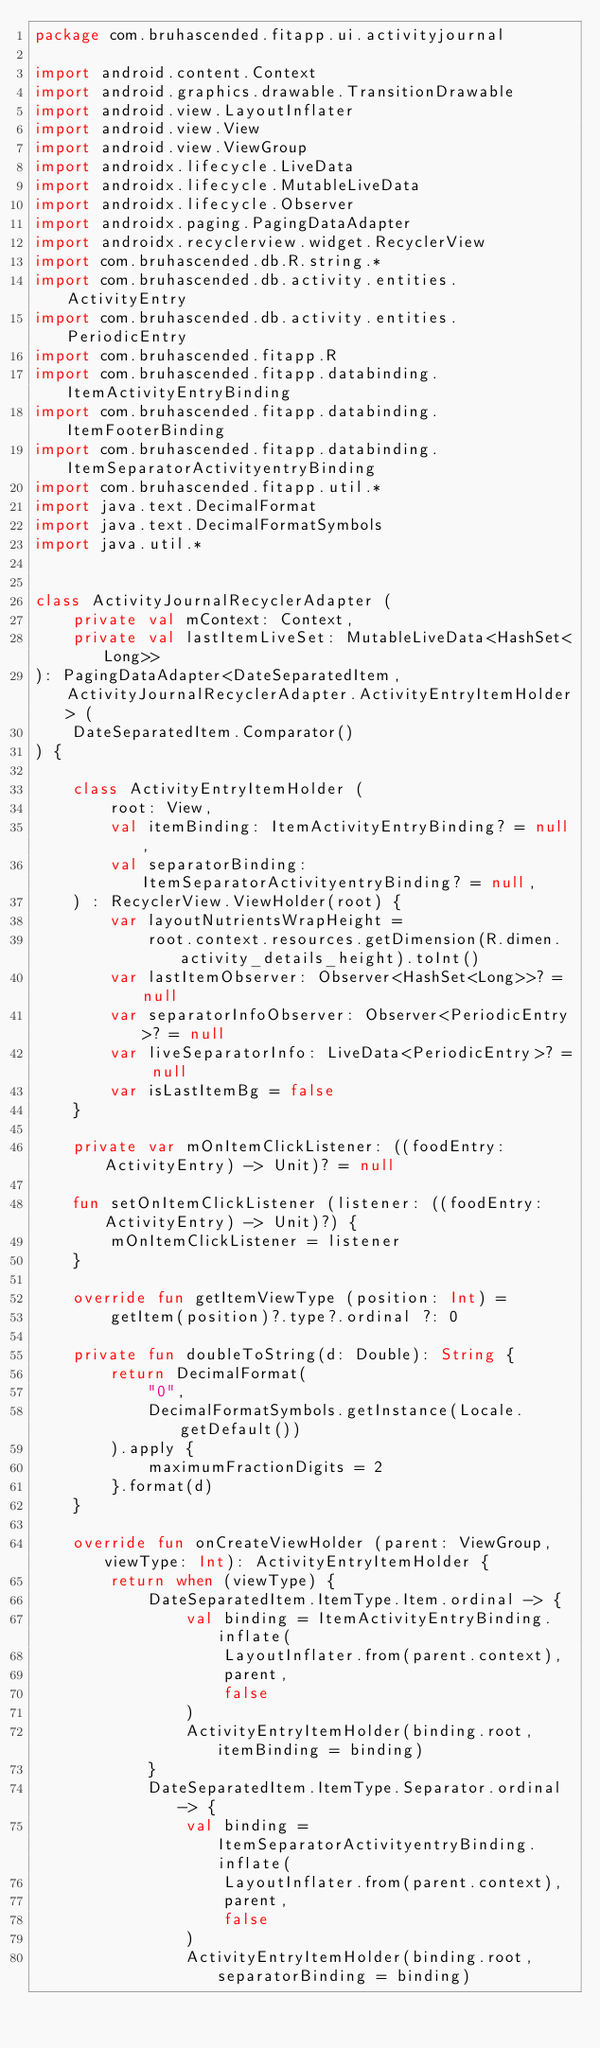Convert code to text. <code><loc_0><loc_0><loc_500><loc_500><_Kotlin_>package com.bruhascended.fitapp.ui.activityjournal

import android.content.Context
import android.graphics.drawable.TransitionDrawable
import android.view.LayoutInflater
import android.view.View
import android.view.ViewGroup
import androidx.lifecycle.LiveData
import androidx.lifecycle.MutableLiveData
import androidx.lifecycle.Observer
import androidx.paging.PagingDataAdapter
import androidx.recyclerview.widget.RecyclerView
import com.bruhascended.db.R.string.*
import com.bruhascended.db.activity.entities.ActivityEntry
import com.bruhascended.db.activity.entities.PeriodicEntry
import com.bruhascended.fitapp.R
import com.bruhascended.fitapp.databinding.ItemActivityEntryBinding
import com.bruhascended.fitapp.databinding.ItemFooterBinding
import com.bruhascended.fitapp.databinding.ItemSeparatorActivityentryBinding
import com.bruhascended.fitapp.util.*
import java.text.DecimalFormat
import java.text.DecimalFormatSymbols
import java.util.*


class ActivityJournalRecyclerAdapter (
    private val mContext: Context,
    private val lastItemLiveSet: MutableLiveData<HashSet<Long>>
): PagingDataAdapter<DateSeparatedItem, ActivityJournalRecyclerAdapter.ActivityEntryItemHolder> (
    DateSeparatedItem.Comparator()
) {

    class ActivityEntryItemHolder (
        root: View,
        val itemBinding: ItemActivityEntryBinding? = null,
        val separatorBinding: ItemSeparatorActivityentryBinding? = null,
    ) : RecyclerView.ViewHolder(root) {
        var layoutNutrientsWrapHeight =
            root.context.resources.getDimension(R.dimen.activity_details_height).toInt()
        var lastItemObserver: Observer<HashSet<Long>>? = null
        var separatorInfoObserver: Observer<PeriodicEntry>? = null
        var liveSeparatorInfo: LiveData<PeriodicEntry>? = null
        var isLastItemBg = false
    }

    private var mOnItemClickListener: ((foodEntry: ActivityEntry) -> Unit)? = null

    fun setOnItemClickListener (listener: ((foodEntry: ActivityEntry) -> Unit)?) {
        mOnItemClickListener = listener
    }

    override fun getItemViewType (position: Int) =
        getItem(position)?.type?.ordinal ?: 0

    private fun doubleToString(d: Double): String {
        return DecimalFormat(
            "0",
            DecimalFormatSymbols.getInstance(Locale.getDefault())
        ).apply {
            maximumFractionDigits = 2
        }.format(d)
    }

    override fun onCreateViewHolder (parent: ViewGroup, viewType: Int): ActivityEntryItemHolder {
        return when (viewType) {
            DateSeparatedItem.ItemType.Item.ordinal -> {
                val binding = ItemActivityEntryBinding.inflate(
                    LayoutInflater.from(parent.context),
                    parent,
                    false
                )
                ActivityEntryItemHolder(binding.root, itemBinding = binding)
            }
            DateSeparatedItem.ItemType.Separator.ordinal -> {
                val binding = ItemSeparatorActivityentryBinding.inflate(
                    LayoutInflater.from(parent.context),
                    parent,
                    false
                )
                ActivityEntryItemHolder(binding.root, separatorBinding = binding)</code> 